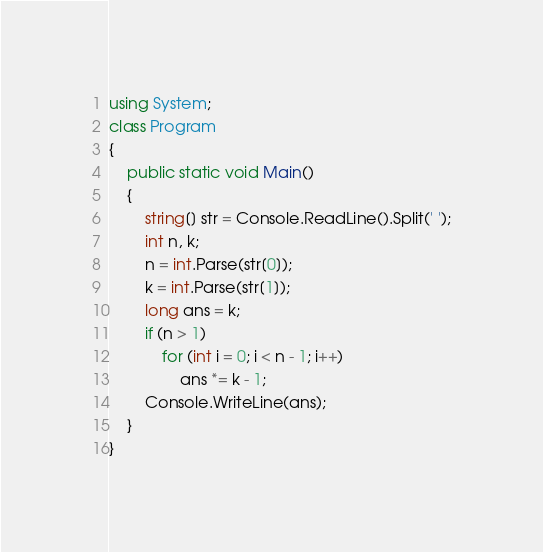Convert code to text. <code><loc_0><loc_0><loc_500><loc_500><_C#_>using System;
class Program
{
    public static void Main()
    {
        string[] str = Console.ReadLine().Split(' ');
        int n, k;
        n = int.Parse(str[0]);
        k = int.Parse(str[1]);
        long ans = k;
        if (n > 1)
            for (int i = 0; i < n - 1; i++)
                ans *= k - 1;
        Console.WriteLine(ans);
    }
}</code> 